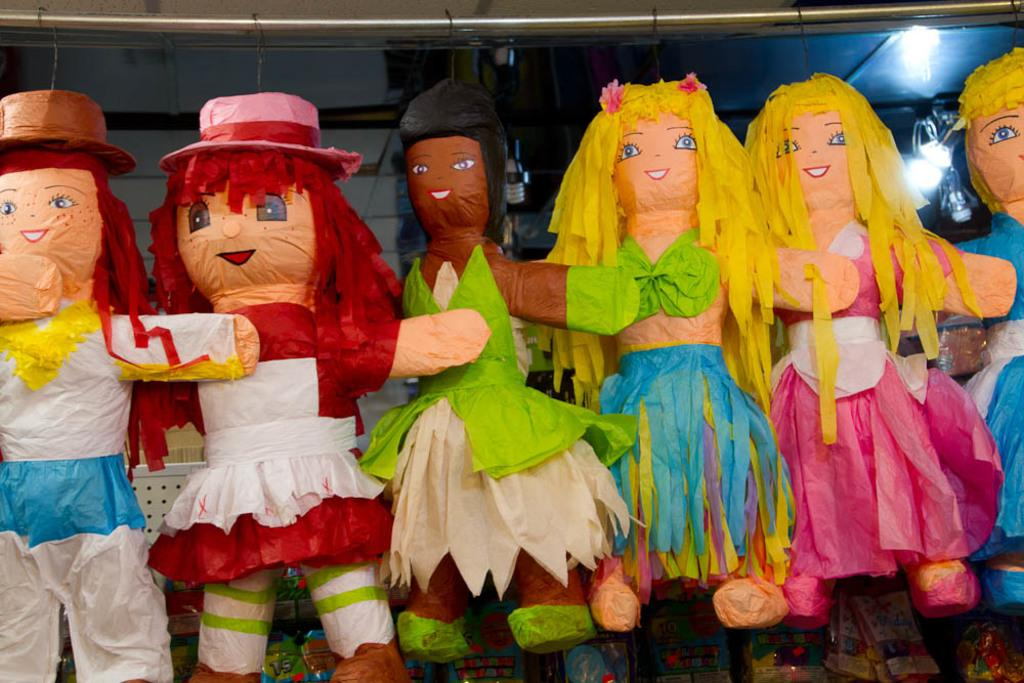What type of dolls are present in the image? There are dolls made of paper in the image. Can you describe the lighting in the image? There are lights at the top on the right side of the image. What type of pen is being used to adjust the scene in the image? There is no pen or scene adjustment present in the image; it only features paper dolls and lights. 